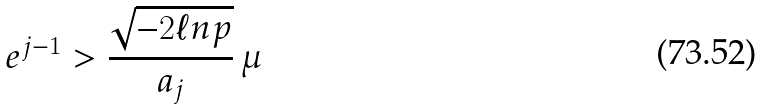<formula> <loc_0><loc_0><loc_500><loc_500>e ^ { j - 1 } > \frac { \sqrt { - 2 \ell n p } } { a _ { j } } \, \mu</formula> 